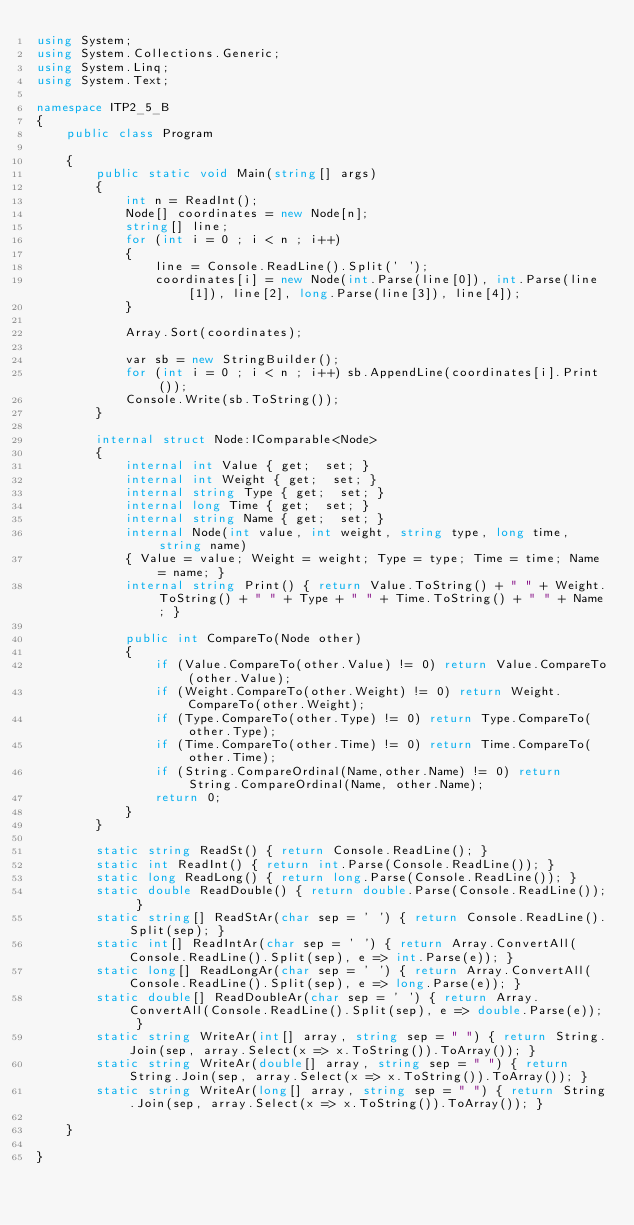<code> <loc_0><loc_0><loc_500><loc_500><_C#_>using System;
using System.Collections.Generic;
using System.Linq;
using System.Text;

namespace ITP2_5_B
{
    public class Program

    {
        public static void Main(string[] args)
        {
            int n = ReadInt();
            Node[] coordinates = new Node[n];
            string[] line;
            for (int i = 0 ; i < n ; i++)
            {
                line = Console.ReadLine().Split(' ');
                coordinates[i] = new Node(int.Parse(line[0]), int.Parse(line[1]), line[2], long.Parse(line[3]), line[4]);
            }

            Array.Sort(coordinates);

            var sb = new StringBuilder();
            for (int i = 0 ; i < n ; i++) sb.AppendLine(coordinates[i].Print());
            Console.Write(sb.ToString());
        }

        internal struct Node:IComparable<Node>
        {
            internal int Value { get;  set; }
            internal int Weight { get;  set; }
            internal string Type { get;  set; }
            internal long Time { get;  set; }
            internal string Name { get;  set; }
            internal Node(int value, int weight, string type, long time, string name)
            { Value = value; Weight = weight; Type = type; Time = time; Name = name; }
            internal string Print() { return Value.ToString() + " " + Weight.ToString() + " " + Type + " " + Time.ToString() + " " + Name; }

            public int CompareTo(Node other)
            {
                if (Value.CompareTo(other.Value) != 0) return Value.CompareTo(other.Value);
                if (Weight.CompareTo(other.Weight) != 0) return Weight.CompareTo(other.Weight);
                if (Type.CompareTo(other.Type) != 0) return Type.CompareTo(other.Type);
                if (Time.CompareTo(other.Time) != 0) return Time.CompareTo(other.Time);
                if (String.CompareOrdinal(Name,other.Name) != 0) return String.CompareOrdinal(Name, other.Name);
                return 0;
            }
        }

        static string ReadSt() { return Console.ReadLine(); }
        static int ReadInt() { return int.Parse(Console.ReadLine()); }
        static long ReadLong() { return long.Parse(Console.ReadLine()); }
        static double ReadDouble() { return double.Parse(Console.ReadLine()); }
        static string[] ReadStAr(char sep = ' ') { return Console.ReadLine().Split(sep); }
        static int[] ReadIntAr(char sep = ' ') { return Array.ConvertAll(Console.ReadLine().Split(sep), e => int.Parse(e)); }
        static long[] ReadLongAr(char sep = ' ') { return Array.ConvertAll(Console.ReadLine().Split(sep), e => long.Parse(e)); }
        static double[] ReadDoubleAr(char sep = ' ') { return Array.ConvertAll(Console.ReadLine().Split(sep), e => double.Parse(e)); }
        static string WriteAr(int[] array, string sep = " ") { return String.Join(sep, array.Select(x => x.ToString()).ToArray()); }
        static string WriteAr(double[] array, string sep = " ") { return String.Join(sep, array.Select(x => x.ToString()).ToArray()); }
        static string WriteAr(long[] array, string sep = " ") { return String.Join(sep, array.Select(x => x.ToString()).ToArray()); }

    }

}

</code> 